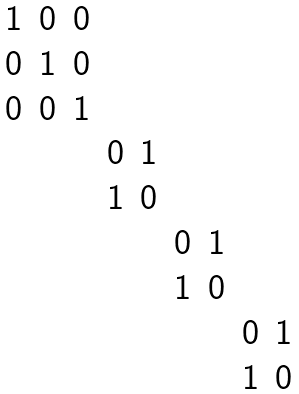<formula> <loc_0><loc_0><loc_500><loc_500>\begin{matrix} 1 & 0 & 0 & & & & & \\ 0 & 1 & 0 & & & & & \\ 0 & 0 & 1 & & & & & \\ & & & 0 & 1 & & & & \\ & & & 1 & 0 & & & & \\ & & & & & 0 & 1 & & \\ & & & & & 1 & 0 & & \\ & & & & & & & 0 & 1 \\ & & & & & & & 1 & 0 \end{matrix}</formula> 